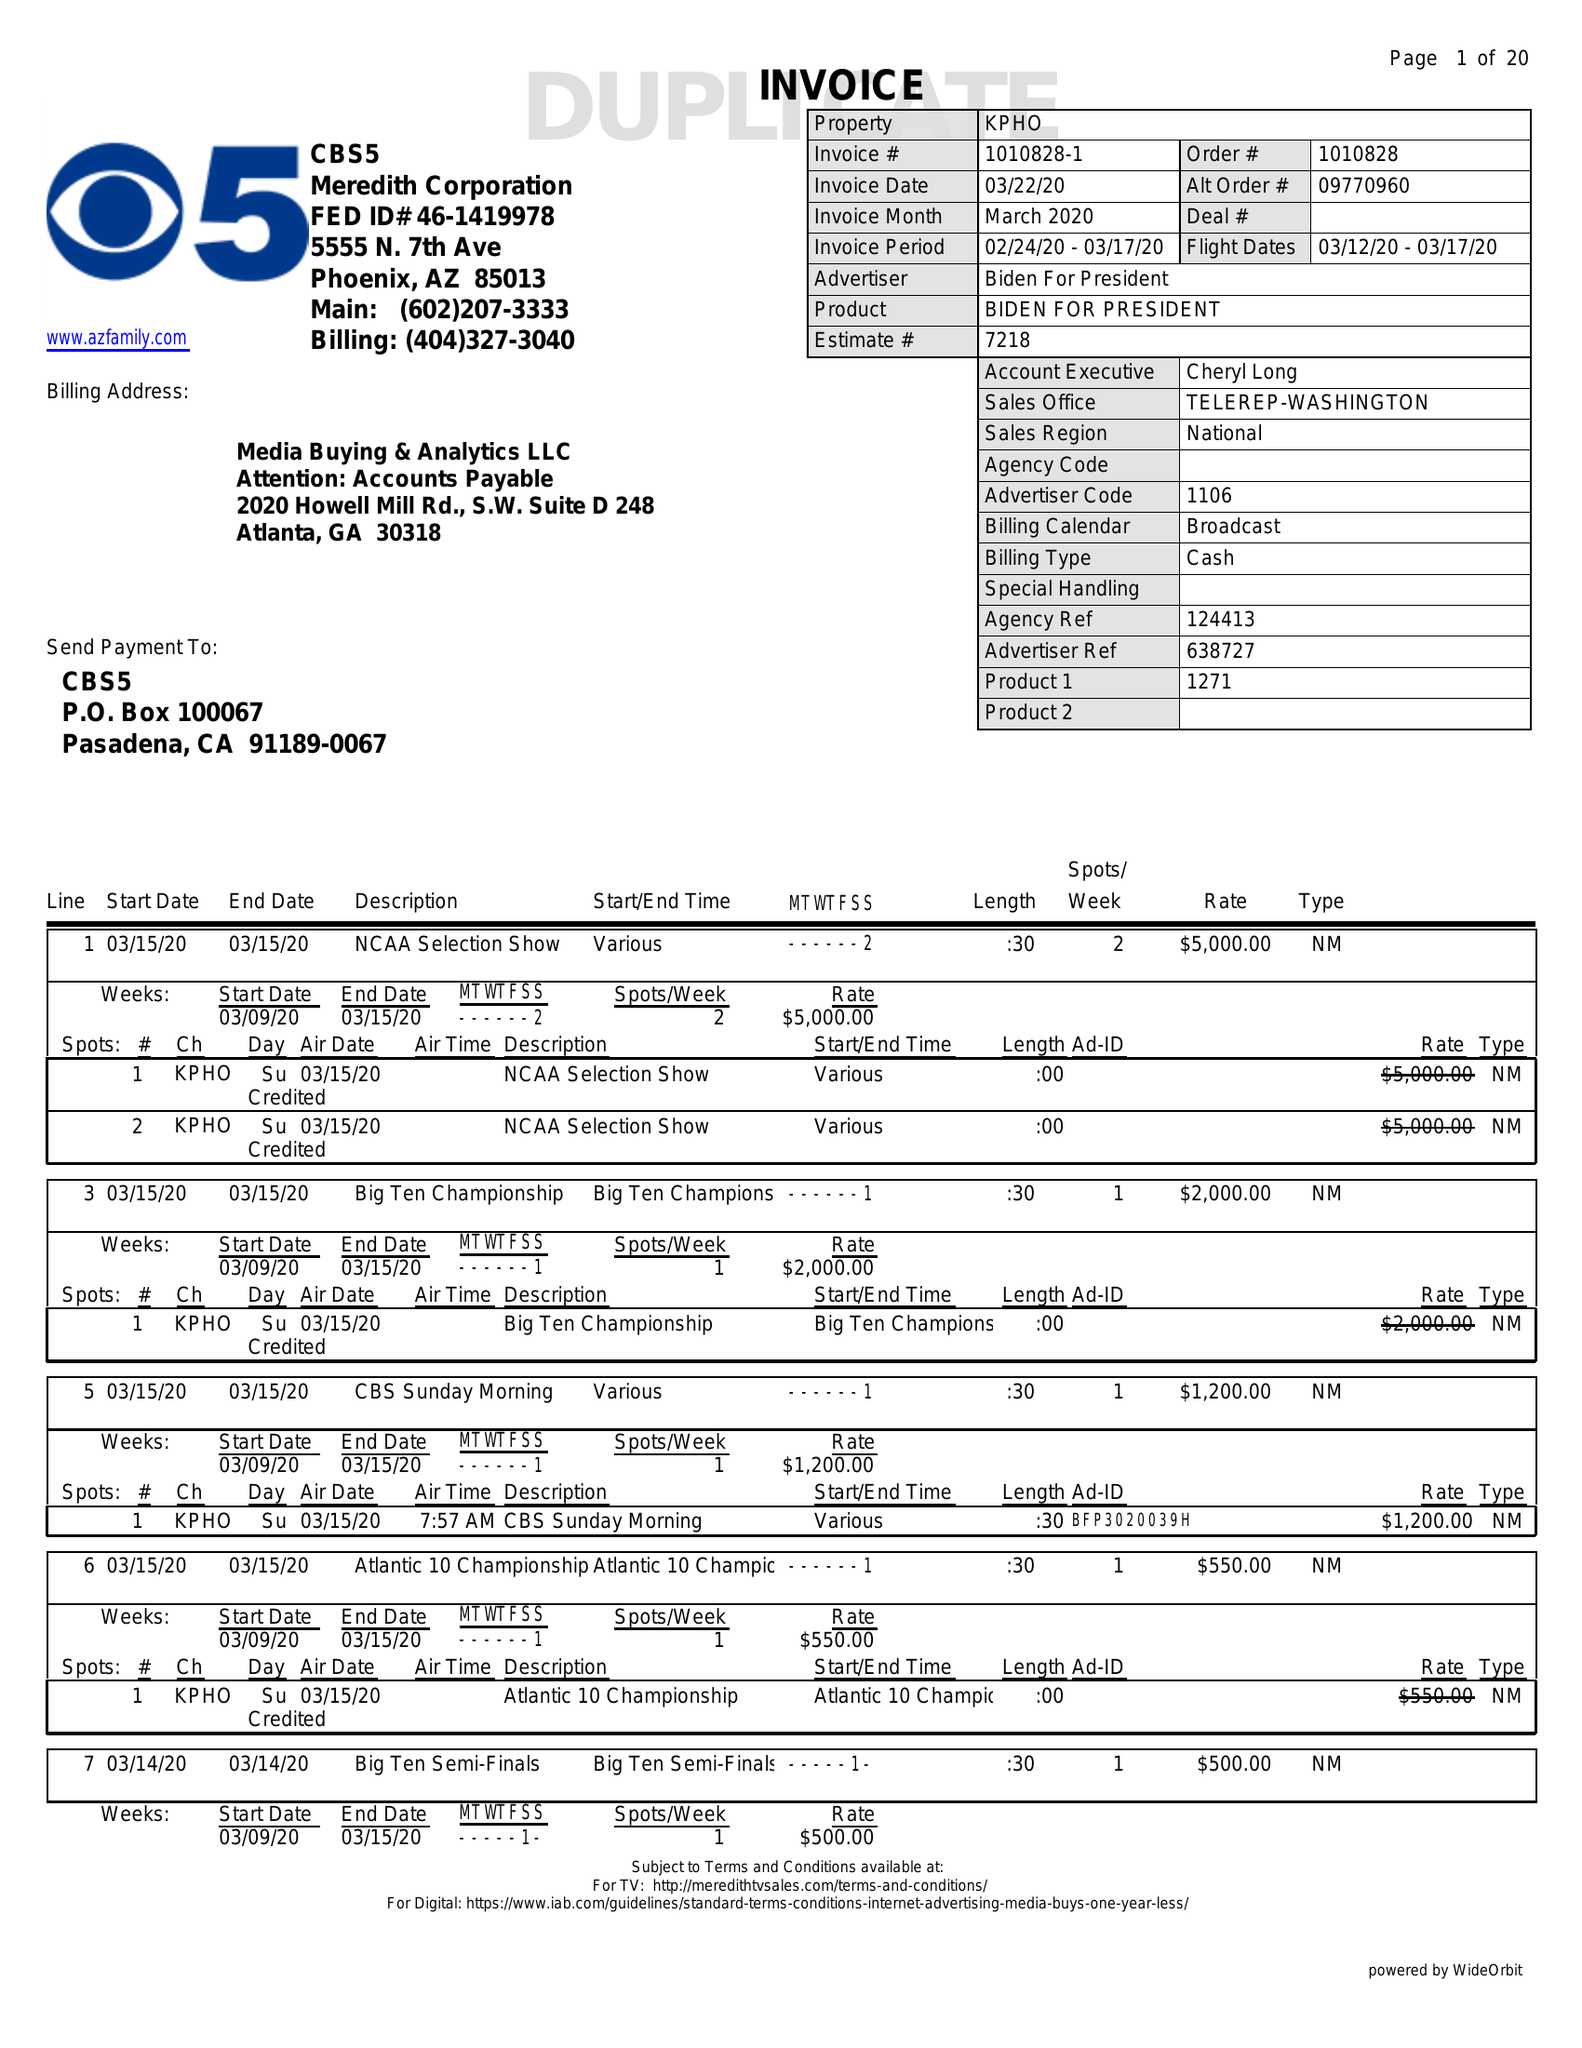What is the value for the gross_amount?
Answer the question using a single word or phrase. 114690.00 